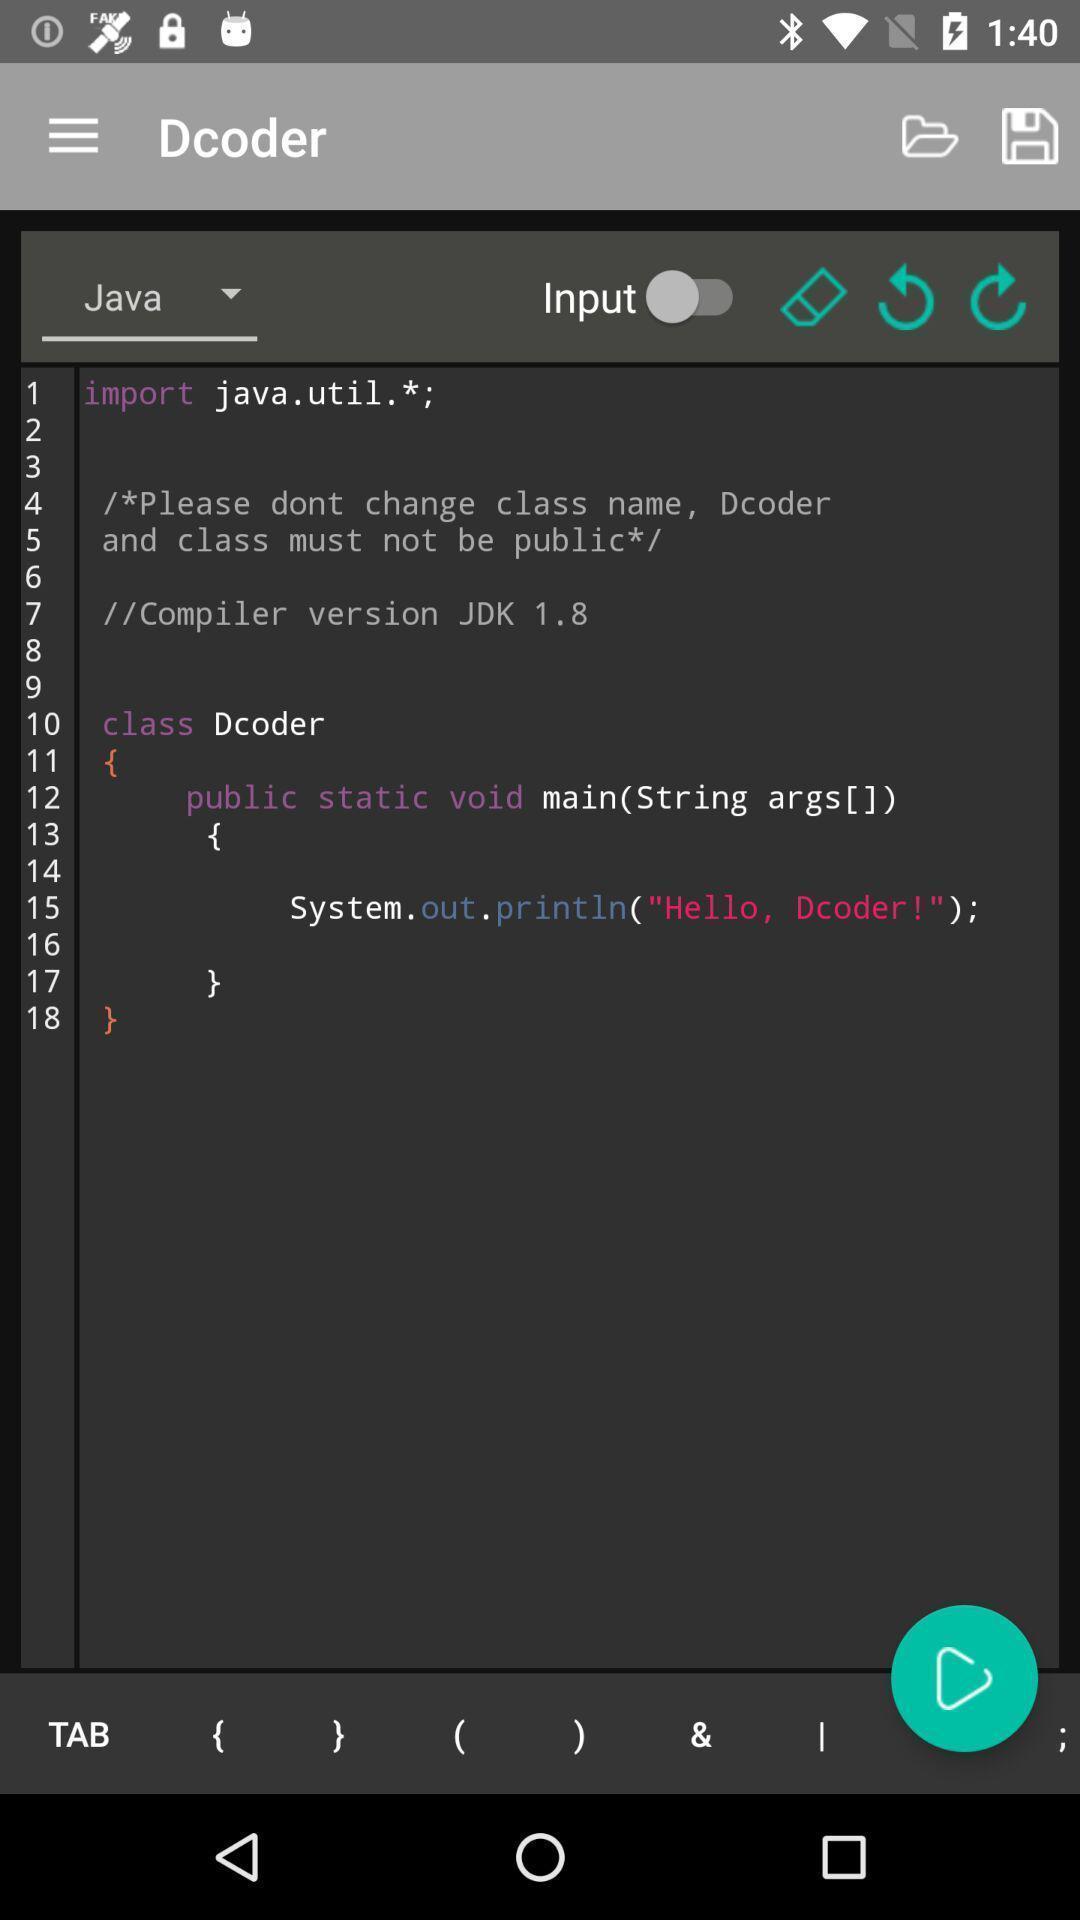Describe this image in words. Screen page of a learning application. 